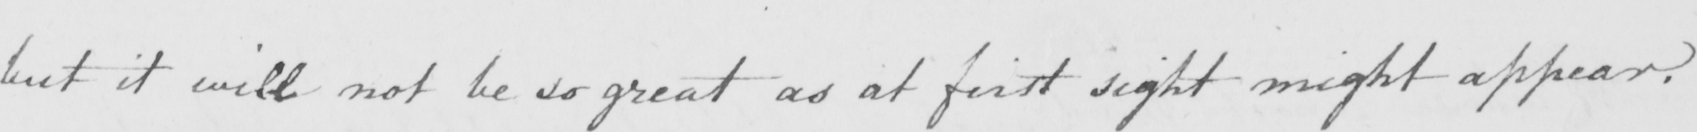Please transcribe the handwritten text in this image. but it will not be so great as at first sight might appear . 